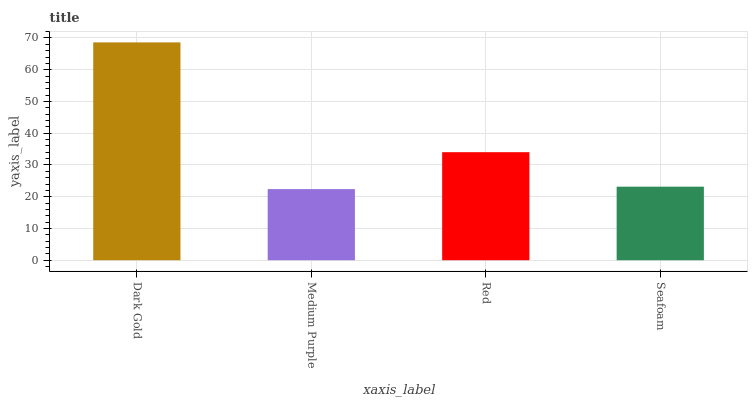Is Medium Purple the minimum?
Answer yes or no. Yes. Is Dark Gold the maximum?
Answer yes or no. Yes. Is Red the minimum?
Answer yes or no. No. Is Red the maximum?
Answer yes or no. No. Is Red greater than Medium Purple?
Answer yes or no. Yes. Is Medium Purple less than Red?
Answer yes or no. Yes. Is Medium Purple greater than Red?
Answer yes or no. No. Is Red less than Medium Purple?
Answer yes or no. No. Is Red the high median?
Answer yes or no. Yes. Is Seafoam the low median?
Answer yes or no. Yes. Is Dark Gold the high median?
Answer yes or no. No. Is Dark Gold the low median?
Answer yes or no. No. 